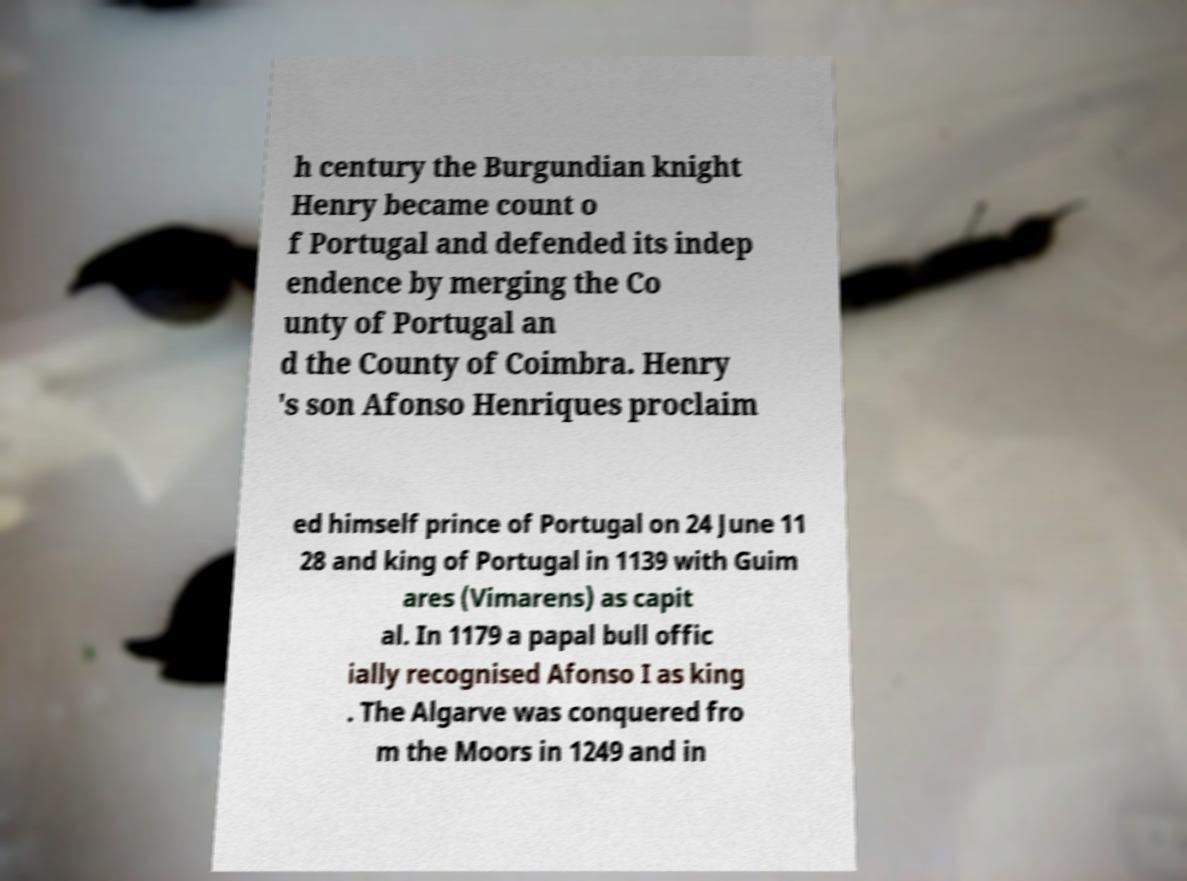There's text embedded in this image that I need extracted. Can you transcribe it verbatim? h century the Burgundian knight Henry became count o f Portugal and defended its indep endence by merging the Co unty of Portugal an d the County of Coimbra. Henry 's son Afonso Henriques proclaim ed himself prince of Portugal on 24 June 11 28 and king of Portugal in 1139 with Guim ares (Vimarens) as capit al. In 1179 a papal bull offic ially recognised Afonso I as king . The Algarve was conquered fro m the Moors in 1249 and in 